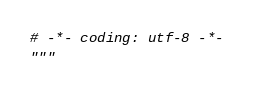Convert code to text. <code><loc_0><loc_0><loc_500><loc_500><_Python_># -*- coding: utf-8 -*-
"""</code> 